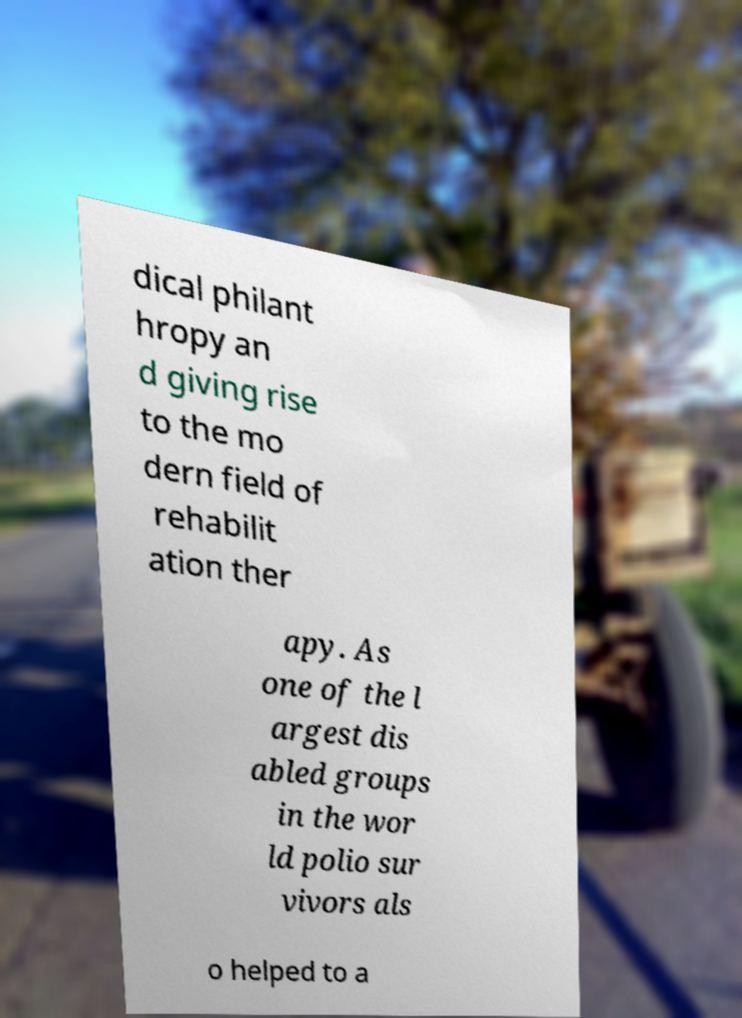Please read and relay the text visible in this image. What does it say? dical philant hropy an d giving rise to the mo dern field of rehabilit ation ther apy. As one of the l argest dis abled groups in the wor ld polio sur vivors als o helped to a 